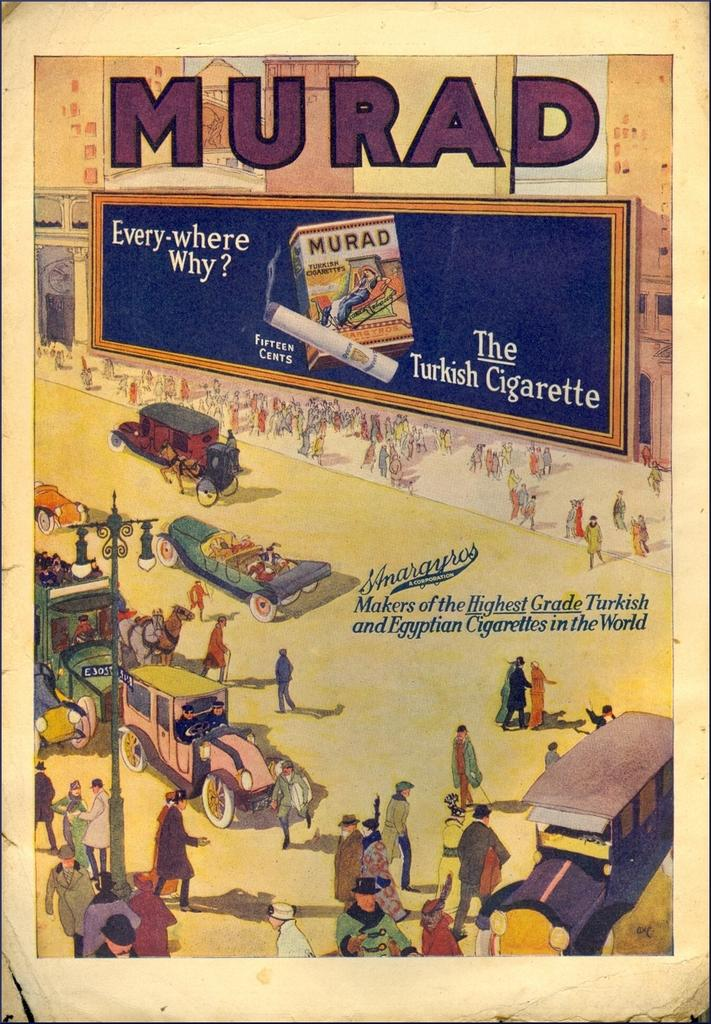<image>
Describe the image concisely. A cigarrette advertisement for Murad showing old cars and people in a city. 